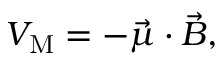Convert formula to latex. <formula><loc_0><loc_0><loc_500><loc_500>V _ { M } = - { \vec { \mu } } \cdot { \vec { B } } ,</formula> 